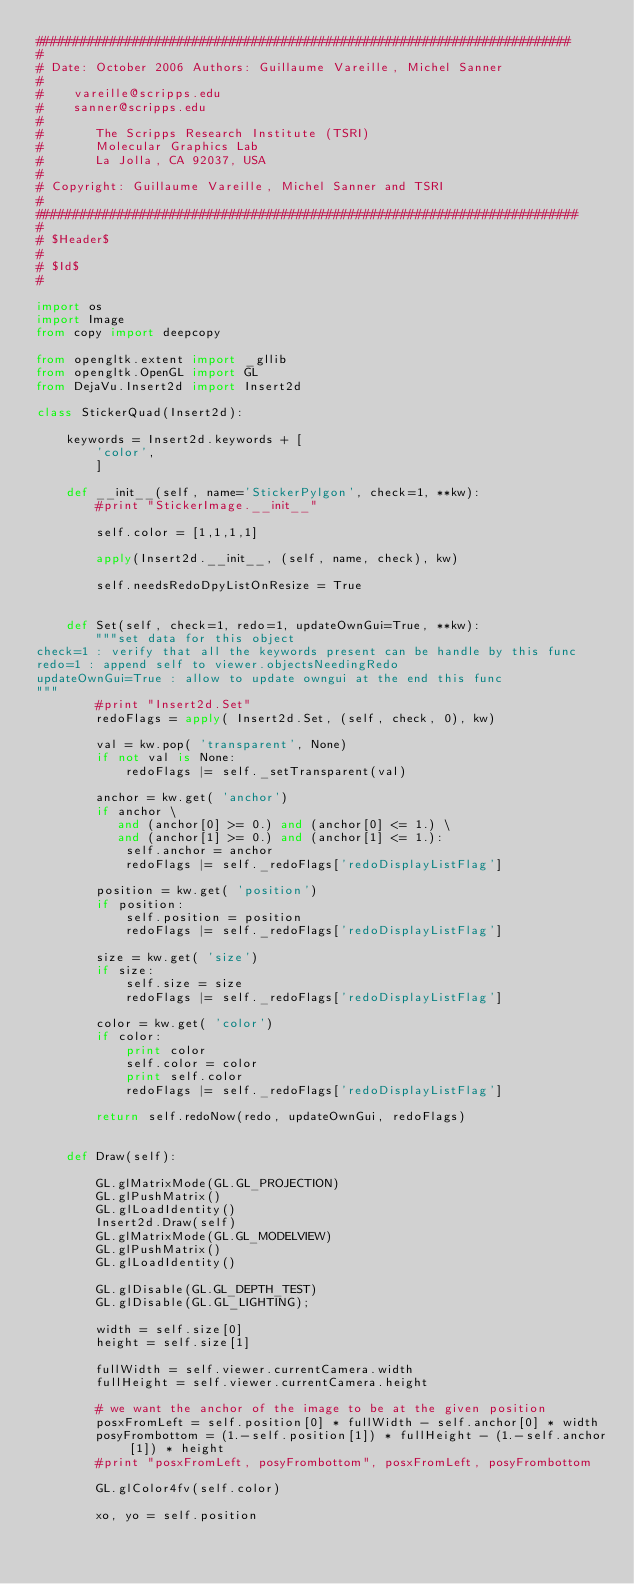Convert code to text. <code><loc_0><loc_0><loc_500><loc_500><_Python_>########################################################################
#
# Date: October 2006 Authors: Guillaume Vareille, Michel Sanner
#
#    vareille@scripps.edu
#    sanner@scripps.edu
#
#       The Scripps Research Institute (TSRI)
#       Molecular Graphics Lab
#       La Jolla, CA 92037, USA
#
# Copyright: Guillaume Vareille, Michel Sanner and TSRI
#
#########################################################################
#
# $Header$
#
# $Id$
#

import os
import Image
from copy import deepcopy

from opengltk.extent import _gllib
from opengltk.OpenGL import GL
from DejaVu.Insert2d import Insert2d

class StickerQuad(Insert2d):

    keywords = Insert2d.keywords + [
        'color',
        ]

    def __init__(self, name='StickerPylgon', check=1, **kw):
        #print "StickerImage.__init__"

        self.color = [1,1,1,1]

        apply(Insert2d.__init__, (self, name, check), kw)

        self.needsRedoDpyListOnResize = True


    def Set(self, check=1, redo=1, updateOwnGui=True, **kw):
        """set data for this object
check=1 : verify that all the keywords present can be handle by this func 
redo=1 : append self to viewer.objectsNeedingRedo
updateOwnGui=True : allow to update owngui at the end this func
"""
        #print "Insert2d.Set"
        redoFlags = apply( Insert2d.Set, (self, check, 0), kw)

        val = kw.pop( 'transparent', None)
        if not val is None:
            redoFlags |= self._setTransparent(val)

        anchor = kw.get( 'anchor')
        if anchor \
           and (anchor[0] >= 0.) and (anchor[0] <= 1.) \
           and (anchor[1] >= 0.) and (anchor[1] <= 1.):
            self.anchor = anchor
            redoFlags |= self._redoFlags['redoDisplayListFlag']

        position = kw.get( 'position')
        if position:
            self.position = position
            redoFlags |= self._redoFlags['redoDisplayListFlag']

        size = kw.get( 'size')
        if size:
            self.size = size
            redoFlags |= self._redoFlags['redoDisplayListFlag']

        color = kw.get( 'color')
        if color:
            print color
            self.color = color
            print self.color
            redoFlags |= self._redoFlags['redoDisplayListFlag']

        return self.redoNow(redo, updateOwnGui, redoFlags)


    def Draw(self):

        GL.glMatrixMode(GL.GL_PROJECTION)
        GL.glPushMatrix()
        GL.glLoadIdentity()
        Insert2d.Draw(self)
        GL.glMatrixMode(GL.GL_MODELVIEW)
        GL.glPushMatrix()
        GL.glLoadIdentity()

        GL.glDisable(GL.GL_DEPTH_TEST)
        GL.glDisable(GL.GL_LIGHTING); 

        width = self.size[0]
        height = self.size[1]

        fullWidth = self.viewer.currentCamera.width
        fullHeight = self.viewer.currentCamera.height

        # we want the anchor of the image to be at the given position
        posxFromLeft = self.position[0] * fullWidth - self.anchor[0] * width
        posyFrombottom = (1.-self.position[1]) * fullHeight - (1.-self.anchor[1]) * height
        #print "posxFromLeft, posyFrombottom", posxFromLeft, posyFrombottom

        GL.glColor4fv(self.color)
        
        xo, yo = self.position</code> 